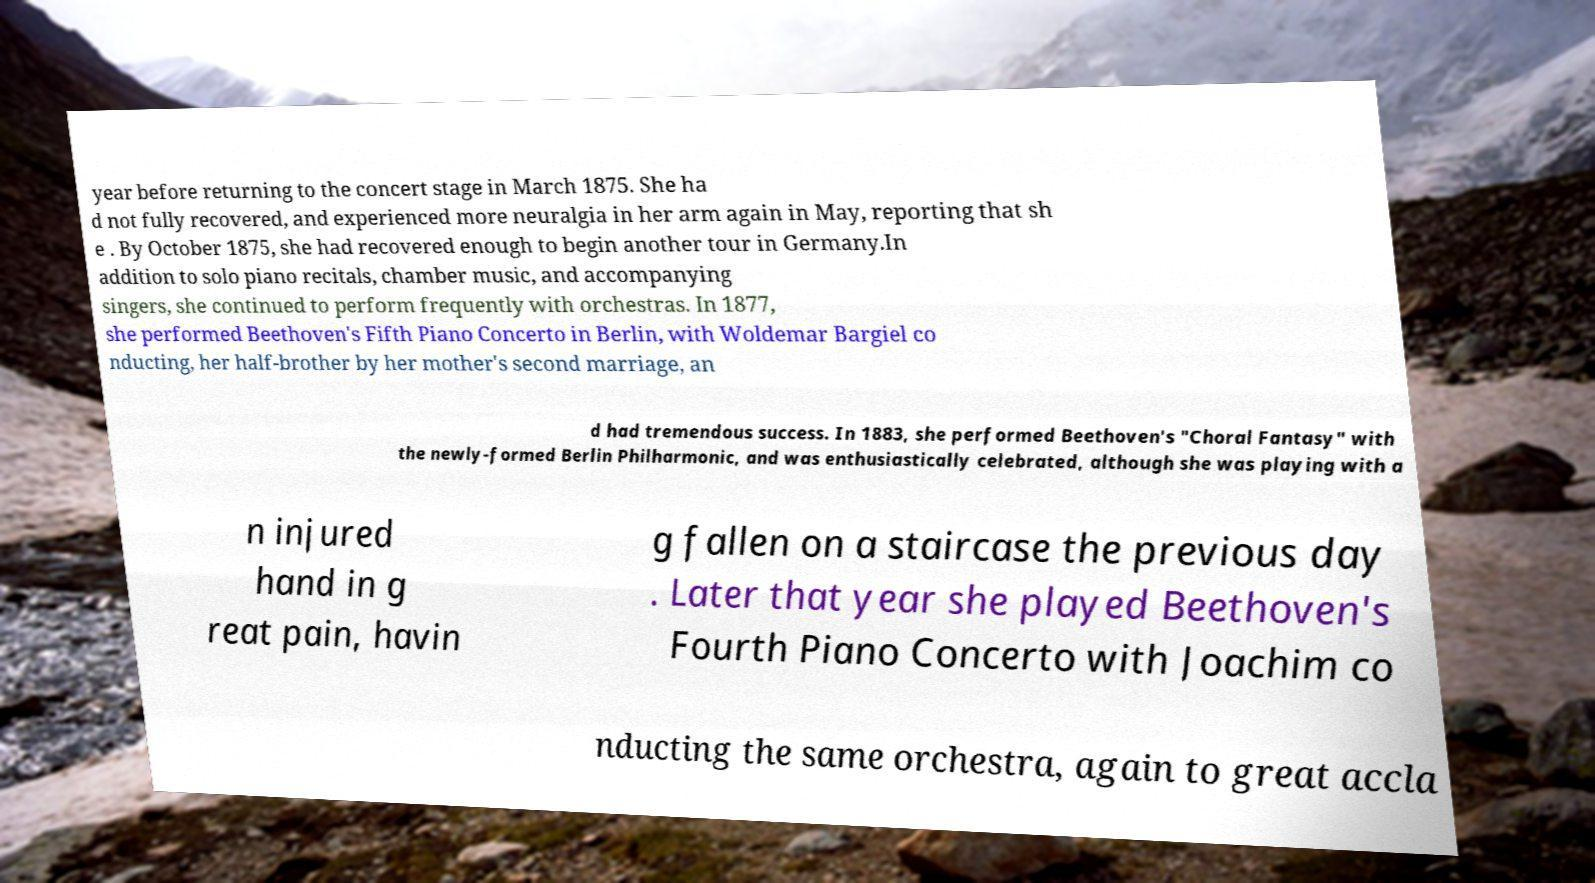Can you accurately transcribe the text from the provided image for me? year before returning to the concert stage in March 1875. She ha d not fully recovered, and experienced more neuralgia in her arm again in May, reporting that sh e . By October 1875, she had recovered enough to begin another tour in Germany.In addition to solo piano recitals, chamber music, and accompanying singers, she continued to perform frequently with orchestras. In 1877, she performed Beethoven's Fifth Piano Concerto in Berlin, with Woldemar Bargiel co nducting, her half-brother by her mother's second marriage, an d had tremendous success. In 1883, she performed Beethoven's "Choral Fantasy" with the newly-formed Berlin Philharmonic, and was enthusiastically celebrated, although she was playing with a n injured hand in g reat pain, havin g fallen on a staircase the previous day . Later that year she played Beethoven's Fourth Piano Concerto with Joachim co nducting the same orchestra, again to great accla 